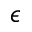<formula> <loc_0><loc_0><loc_500><loc_500>\epsilon</formula> 